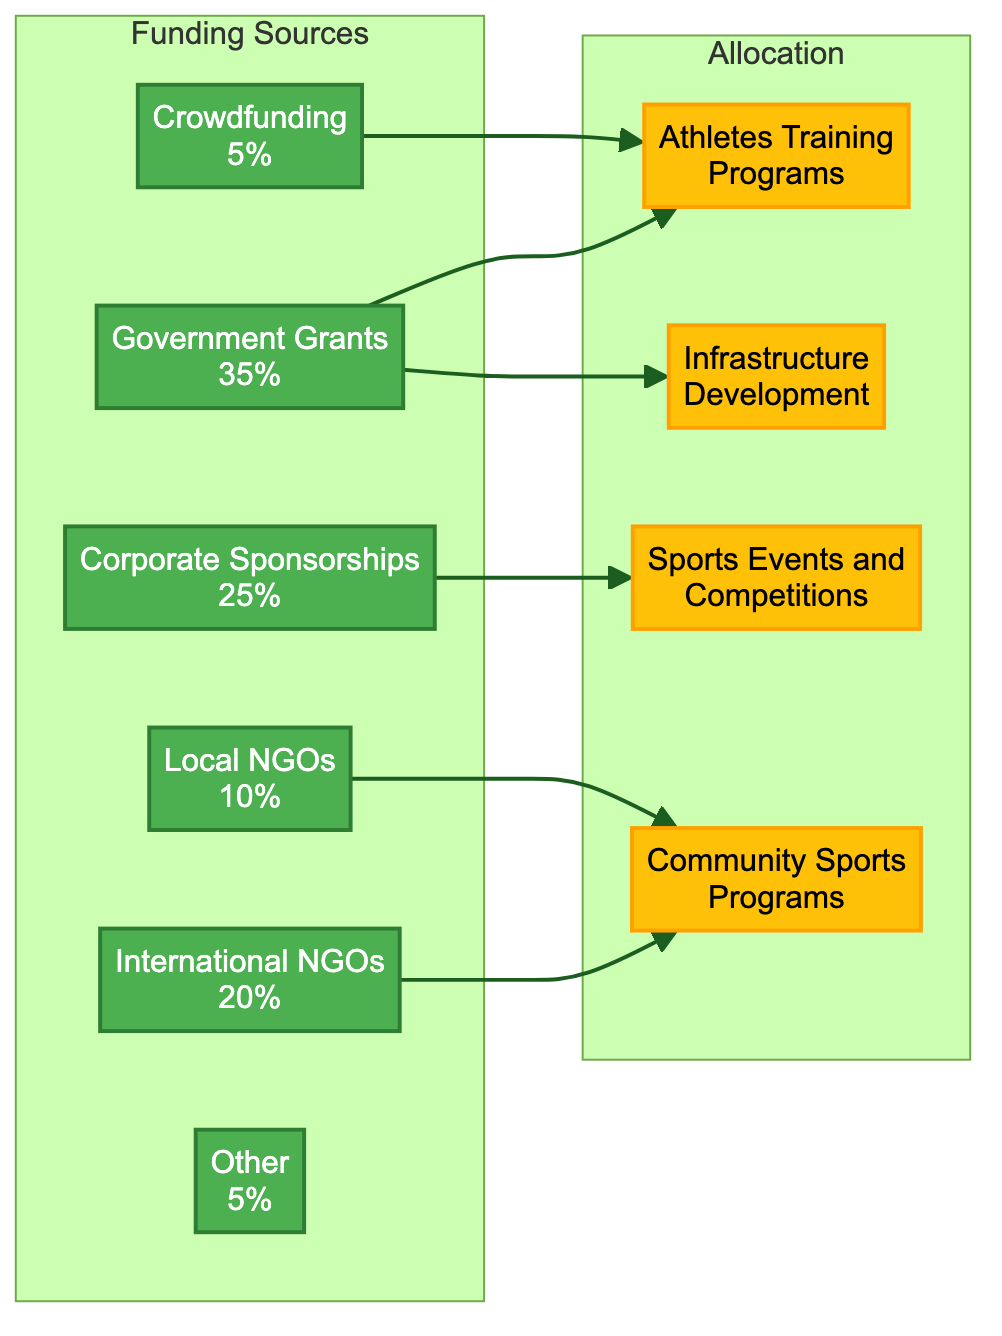What percentage of funding comes from Government Grants? The diagram shows that Government Grants account for 35% of the funding sources. Therefore, the answer is found directly from the node corresponding to Government Grants.
Answer: 35% Which funding source allocates resources to Athletes Training Programs? The diagram indicates that Government Grants and Crowdfunding both allocate funds to Athletes Training Programs, as they have arrows pointing toward this allocation node.
Answer: Government Grants, Crowdfunding What is the percentage of funding from Corporate Sponsorships? The Corporate Sponsorships node in the diagram specifies that it comprises 25% of the total funding sources available for development in African sports.
Answer: 25% How many funding sources are there in the diagram? By counting the nodes in the Funding Sources subgraph, we find six individual sources listed (Government Grants, Corporate Sponsorships, International NGOs, Local NGOs, Crowdfunding, Other).
Answer: 6 Which allocation category receives funding from Local NGOs? The diagram shows that Local NGOs contribute their funding to Community Sports Programs, as indicated by the arrow from the Local NGOs node pointing to this allocation category.
Answer: Community Sports Programs Which funding source is allocated to Sports Events and Competitions? The diagram demonstrates that Corporate Sponsorships exclusively fund Sports Events and Competitions as indicated by the direct arrow from the Corporate Sponsorships node to the Sports Events and Competitions allocation node.
Answer: Corporate Sponsorships How much funding is allocated to Community Sports Programs? Community Sports Programs receive funding from both International NGOs (20%) and Local NGOs (10%), resulting in a total allocation of 30% when combined.
Answer: 30% Which two allocations are funded by Government Grants? The arrows from the Government Grants node indicate that it funds both Athletes Training Programs and Infrastructure Development; thus both these allocations are directly supported by Government Grants.
Answer: Athletes Training Programs, Infrastructure Development What percentage of the funding comes from Crowdfunding? The pie chart in the diagram specifies that Crowdfunding contributes 5% toward the overall funding sources in African sports development.
Answer: 5% 